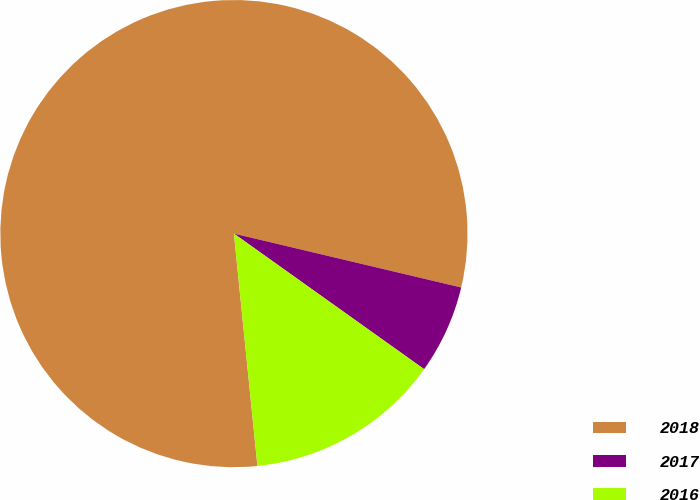Convert chart to OTSL. <chart><loc_0><loc_0><loc_500><loc_500><pie_chart><fcel>2018<fcel>2017<fcel>2016<nl><fcel>80.31%<fcel>6.15%<fcel>13.54%<nl></chart> 